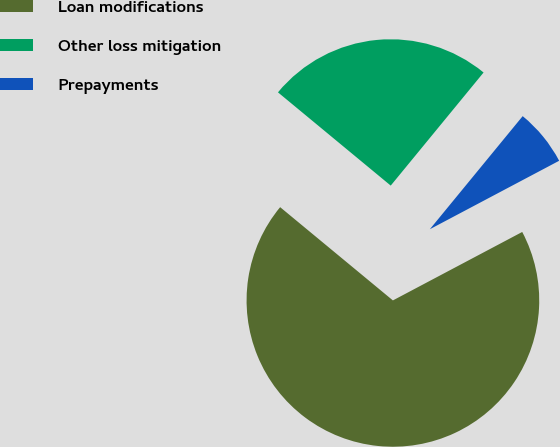Convert chart. <chart><loc_0><loc_0><loc_500><loc_500><pie_chart><fcel>Loan modifications<fcel>Other loss mitigation<fcel>Prepayments<nl><fcel>68.74%<fcel>24.94%<fcel>6.31%<nl></chart> 